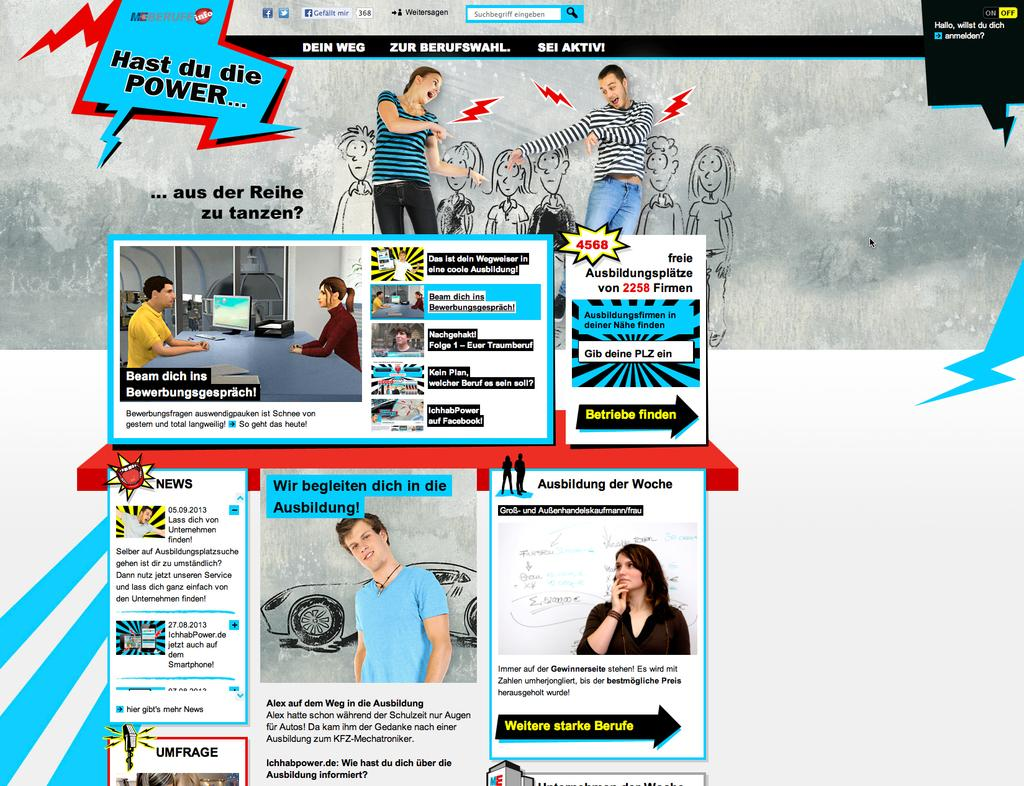What type of page is shown in the image? The image is an advertisement page. What can be found on the page besides the cartoons? There is text on the page. Can you describe the cartoons on the page? The cartoons on the page are likely used to illustrate or enhance the message of the advertisement. How many masks are being worn by the cartoon characters on the page? There are no masks visible on the cartoon characters in the image. What type of team is being advertised on the page? The image does not show any specific team being advertised; it is an advertisement page with text and cartoons. 